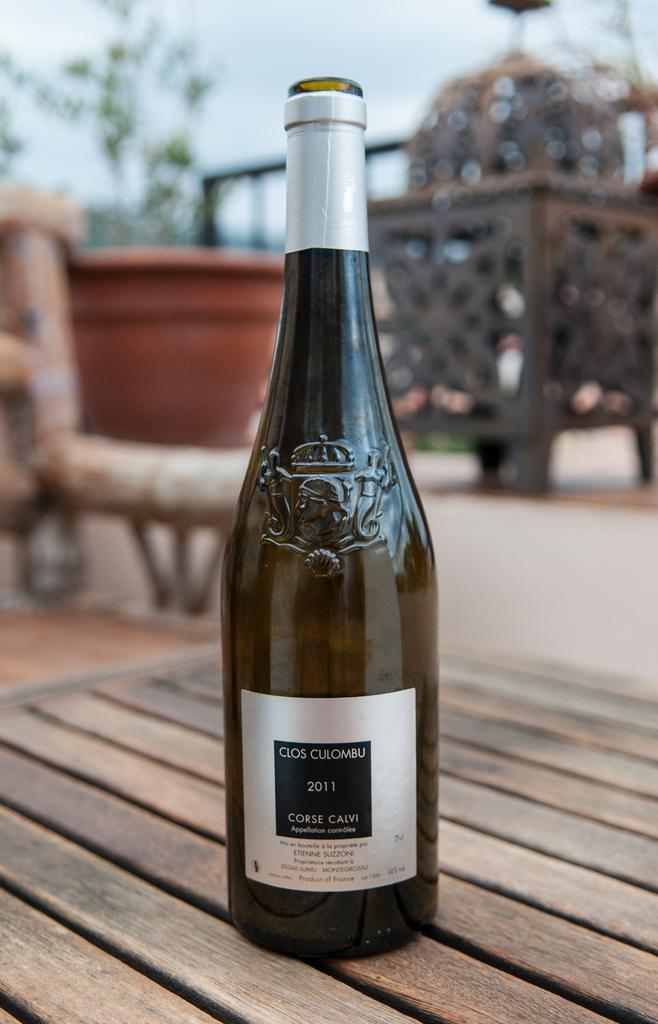<image>
Present a compact description of the photo's key features. The label of a bottle reads "Clos Culombu, 2011, Corse Calvi" and sits on an outdoor table. 